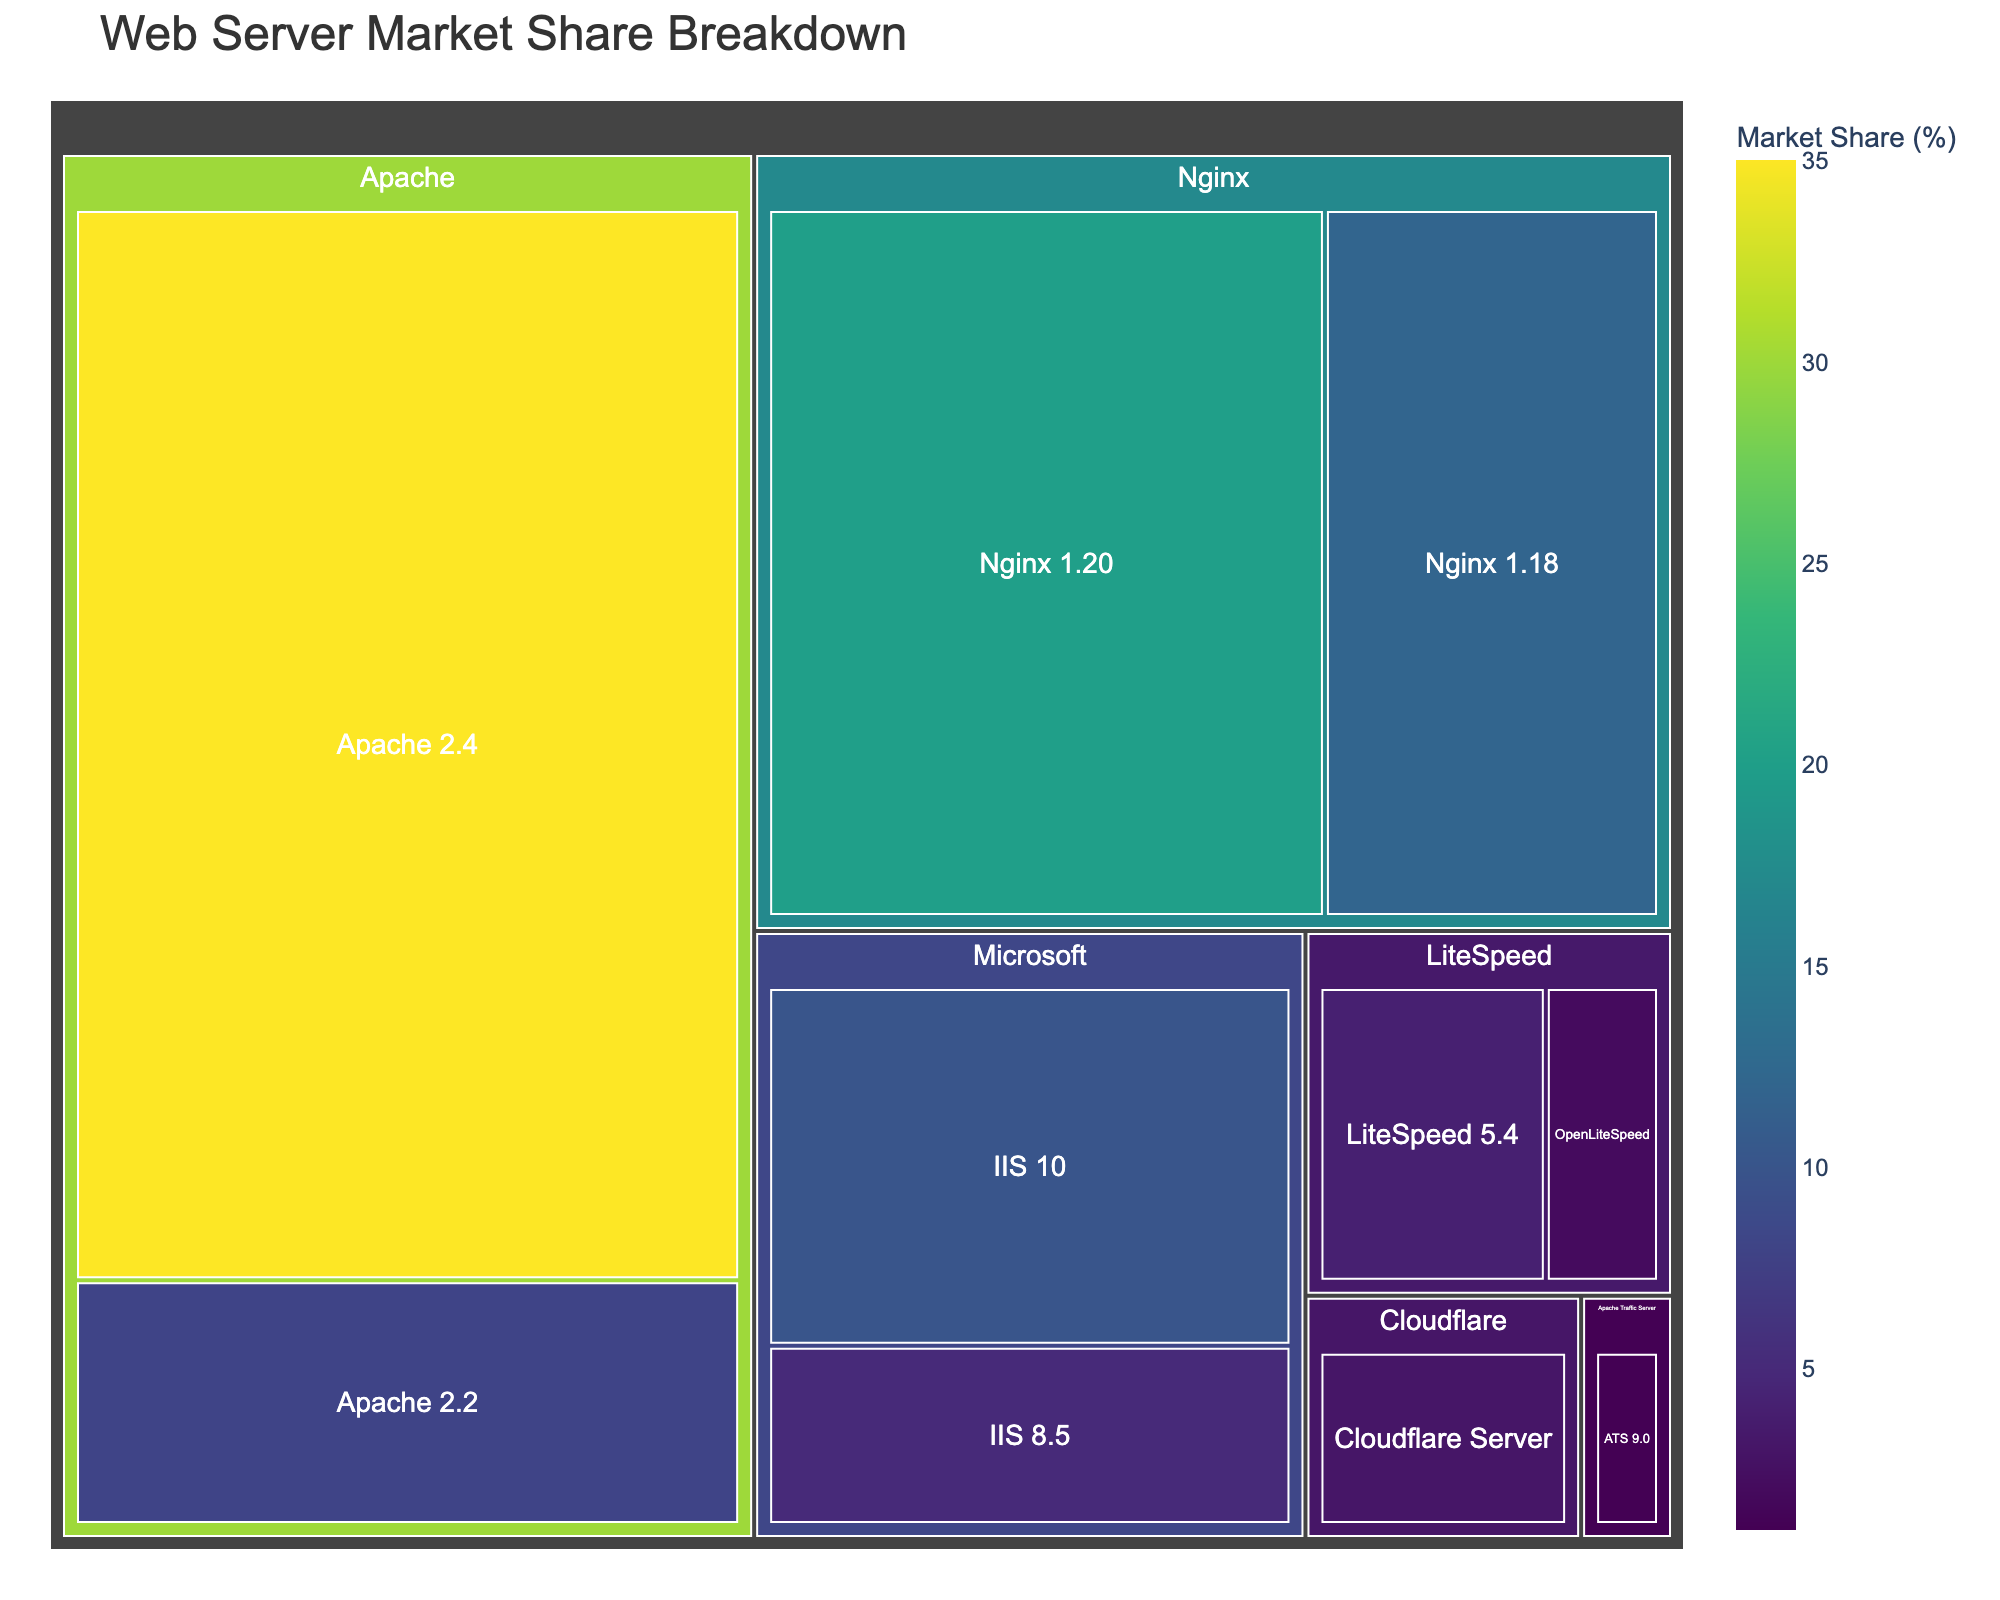How many main categories of web server software are displayed? The figure has distinct color-coded segments for each main category. By looking at the paths in the treemap, you can identify that there are 5 main categories: Apache, Nginx, Microsoft, LiteSpeed, and Cloudflare (with an additional Apache Traffic Server)
Answer: 5 Which subcategory in the Apache category has the highest market share? Within the Apache segment of the treemap, the largest block size under Apache would indicate the highest market share. By examining the labels, 'Apache 2.4' has the highest value.
Answer: Apache 2.4 What is the combined market share of Nginx? By adding the values of all Nginx subcategories: Nginx 1.20 (20%) and Nginx 1.18 (12%), you get 20 + 12.
Answer: 32% Which server type has the smallest share and what is its value? The smallest segment (block) in the treemap corresponds to the smallest market share. According to the data, 'Apache Traffic Server, ATS 9.0' holds the least share with 1%.
Answer: Apache Traffic Server, ATS 9.0, 1% How does the market share of LiteSpeed compare with that of Microsoft's IIS 10? Comparing the values, LiteSpeed has a total of 6% (LiteSpeed 5.4 = 4%, OpenLiteSpeed = 2%) and IIS 10 has 10%. Hence, LiteSpeed's share is less than that of IIS 10.
Answer: LiteSpeed's share is less What is the average market share of all subcategories within the Apache category? First, sum the values of all Apache subcategories: 35% (Apache 2.4) + 8% (Apache 2.2) = 43%. There are 2 subcategories. So, the average is 43 / 2.
Answer: 21.5% Which main category appears to be most dominant in the market based on the figure? The size of the segments in the treemap reflects the dominance of the categories. The Apache category has the largest combined segment, indicating it is the most dominant.
Answer: Apache Are there more subcategories under Apache or Nginx? By counting the number of subcategories under each main category, Apache has 2 (Apache 2.4, Apache 2.2), and Nginx also has 2 (Nginx 1.20, Nginx 1.18). So they have the same number of subcategories.
Answer: The same What is the combined market share of all web server software related to Apache? Summing the values from Apache's subcategories: Apache 2.4 (35%) and Apache 2.2 (8%), the total market share is 35 + 8.
Answer: 43% What percentage of the market is covered by Cloudflare Server? The figure shows Cloudflare Server as a single subcategory under Cloudflare with a value of 3%.
Answer: 3% 